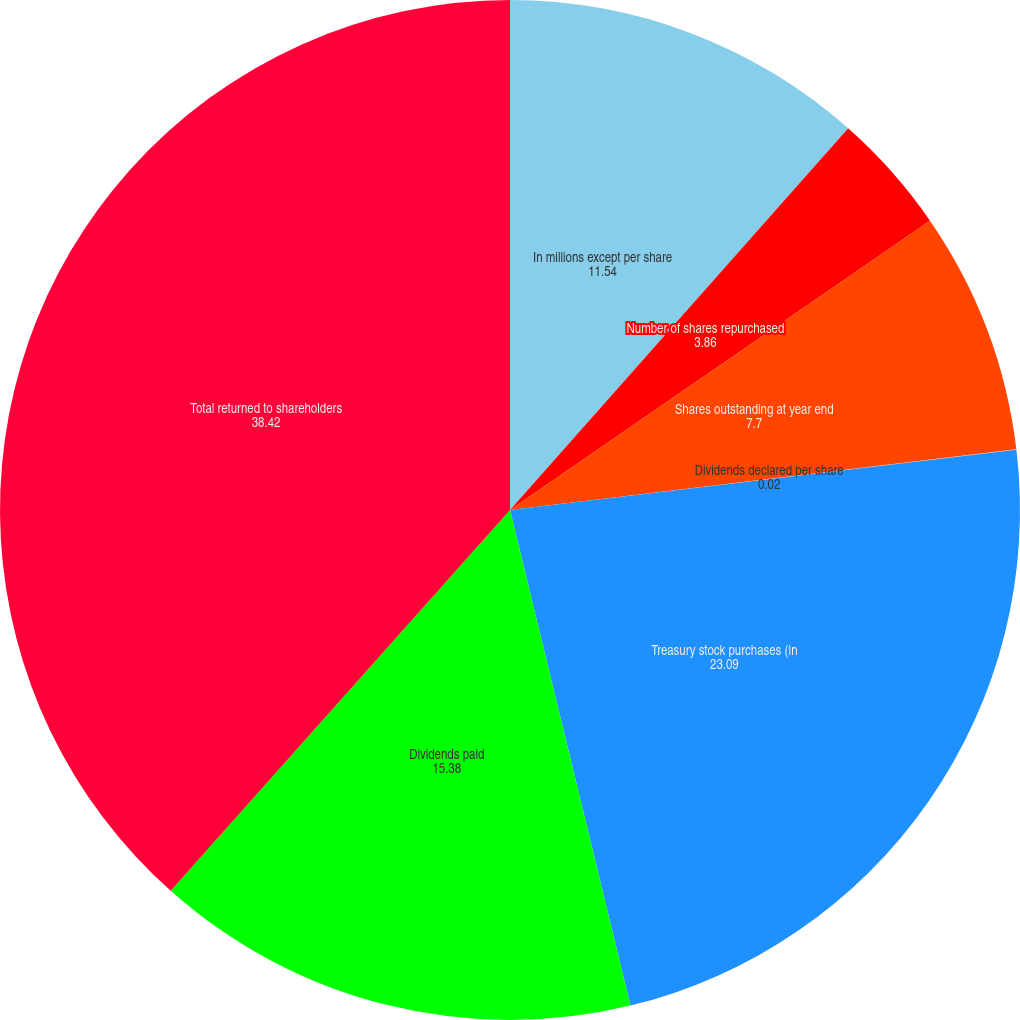<chart> <loc_0><loc_0><loc_500><loc_500><pie_chart><fcel>In millions except per share<fcel>Number of shares repurchased<fcel>Shares outstanding at year end<fcel>Dividends declared per share<fcel>Treasury stock purchases (in<fcel>Dividends paid<fcel>Total returned to shareholders<nl><fcel>11.54%<fcel>3.86%<fcel>7.7%<fcel>0.02%<fcel>23.09%<fcel>15.38%<fcel>38.42%<nl></chart> 